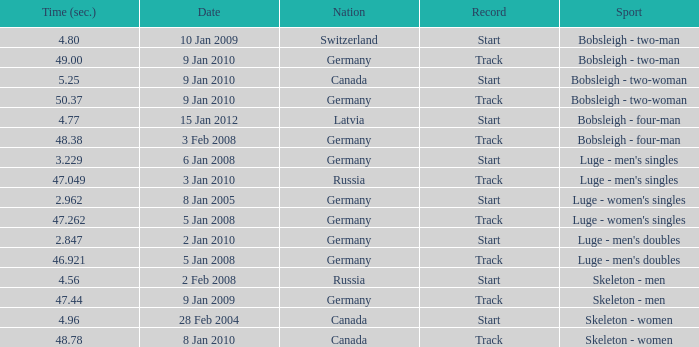In which sport does the time surpass 49? Bobsleigh - two-woman. 